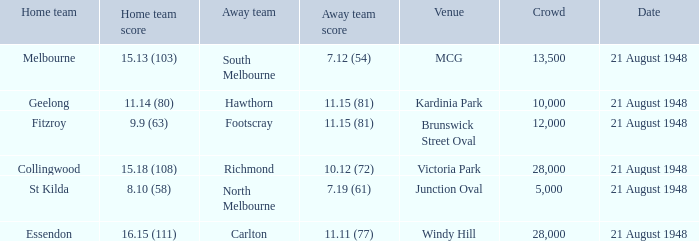What is the highest attendance recorded at victoria park as a venue? 28000.0. 